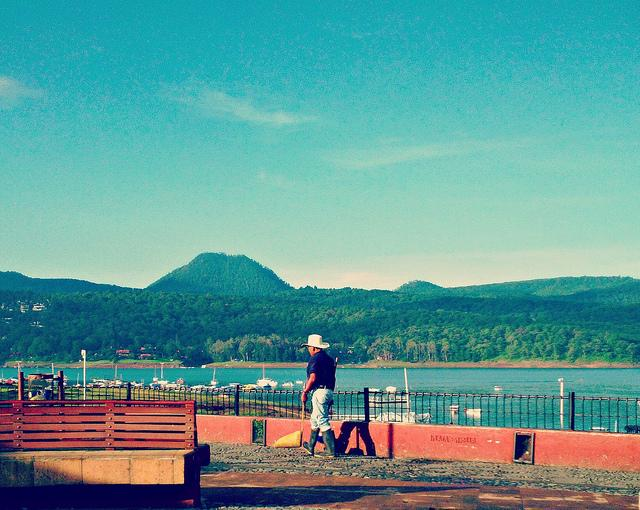What is the man wearing that is made of rubber? Please explain your reasoning. boots. Rubber boots can be worn to protect from wet areas. 